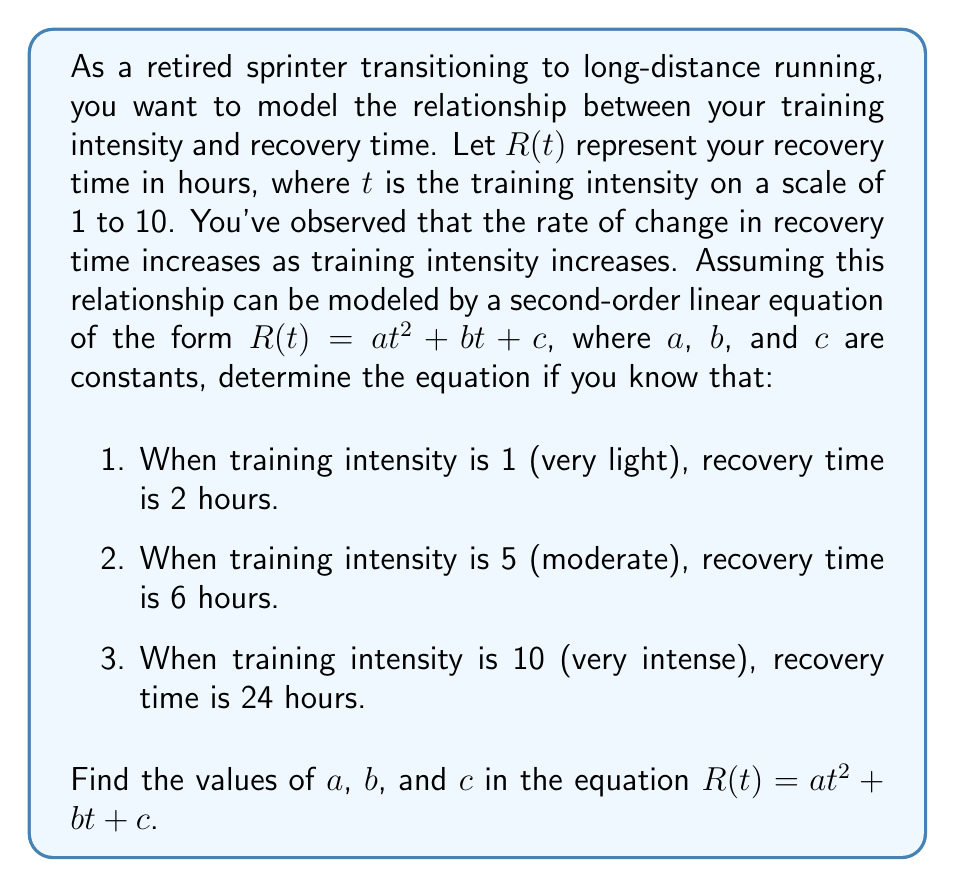Could you help me with this problem? To solve this problem, we'll use the given information to create a system of equations and solve for $a$, $b$, and $c$. Let's approach this step-by-step:

1) We have three points that satisfy the equation $R(t) = at^2 + bt + c$:
   (1, 2), (5, 6), and (10, 24)

2) Let's substitute these points into the equation:
   For (1, 2):  $2 = a(1)^2 + b(1) + c$  or  $2 = a + b + c$
   For (5, 6):  $6 = a(5)^2 + b(5) + c$  or  $6 = 25a + 5b + c$
   For (10, 24): $24 = a(10)^2 + b(10) + c$  or  $24 = 100a + 10b + c$

3) Now we have a system of three equations:
   $a + b + c = 2$      (Equation 1)
   $25a + 5b + c = 6$   (Equation 2)
   $100a + 10b + c = 24$ (Equation 3)

4) Let's subtract Equation 1 from Equation 2:
   $24a + 4b = 4$  or  $6a + b = 1$  (Equation 4)

5) Now subtract Equation 1 from Equation 3:
   $99a + 9b = 22$  (Equation 5)

6) Multiply Equation 4 by 9 and subtract it from Equation 5:
   $99a + 9b = 22$
   $54a + 9b = 9$
   $45a = 13$
   $a = \frac{13}{45} \approx 0.2889$

7) Substitute this value of $a$ back into Equation 4:
   $6(\frac{13}{45}) + b = 1$
   $\frac{78}{45} + b = 1$
   $b = 1 - \frac{78}{45} = -\frac{33}{45} \approx -0.7333$

8) Finally, substitute $a$ and $b$ into Equation 1 to find $c$:
   $\frac{13}{45} + (-\frac{33}{45}) + c = 2$
   $c = 2 - \frac{13}{45} + \frac{33}{45} = 2 + \frac{20}{45} = \frac{110}{45} \approx 2.4444$

Therefore, the equation that models the relationship between training intensity and recovery time is:

$$R(t) = \frac{13}{45}t^2 - \frac{33}{45}t + \frac{110}{45}$$
Answer: $a = \frac{13}{45}$, $b = -\frac{33}{45}$, $c = \frac{110}{45}$

The second-order linear equation is:

$$R(t) = \frac{13}{45}t^2 - \frac{33}{45}t + \frac{110}{45}$$ 